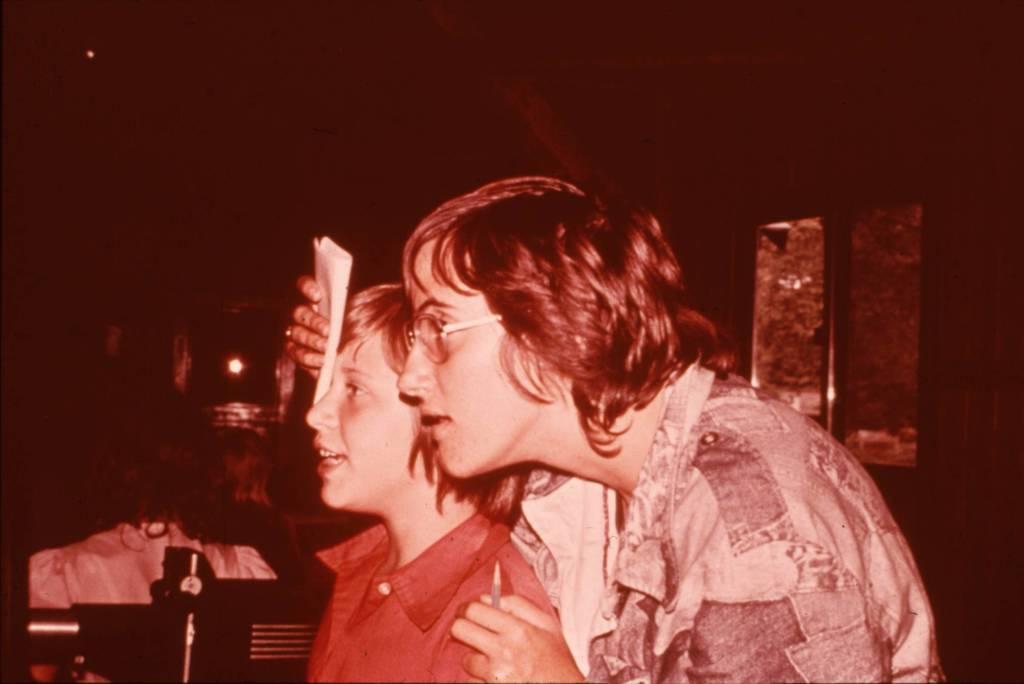Describe this image in one or two sentences. 2 people are present in a room facing towards left. The person at the right is wearing spectacles and holding a pen and paper in his hands. Behind them there is a window. 